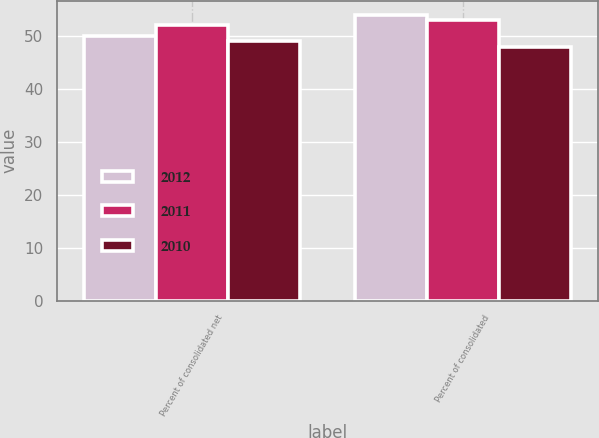<chart> <loc_0><loc_0><loc_500><loc_500><stacked_bar_chart><ecel><fcel>Percent of consolidated net<fcel>Percent of consolidated<nl><fcel>2012<fcel>50<fcel>54<nl><fcel>2011<fcel>52<fcel>53<nl><fcel>2010<fcel>49<fcel>48<nl></chart> 